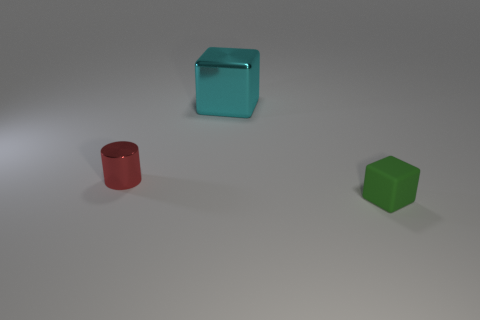Add 2 tiny green matte objects. How many objects exist? 5 Subtract all blocks. How many objects are left? 1 Subtract 0 red balls. How many objects are left? 3 Subtract all blue cylinders. Subtract all tiny green rubber objects. How many objects are left? 2 Add 1 tiny green objects. How many tiny green objects are left? 2 Add 1 tiny cylinders. How many tiny cylinders exist? 2 